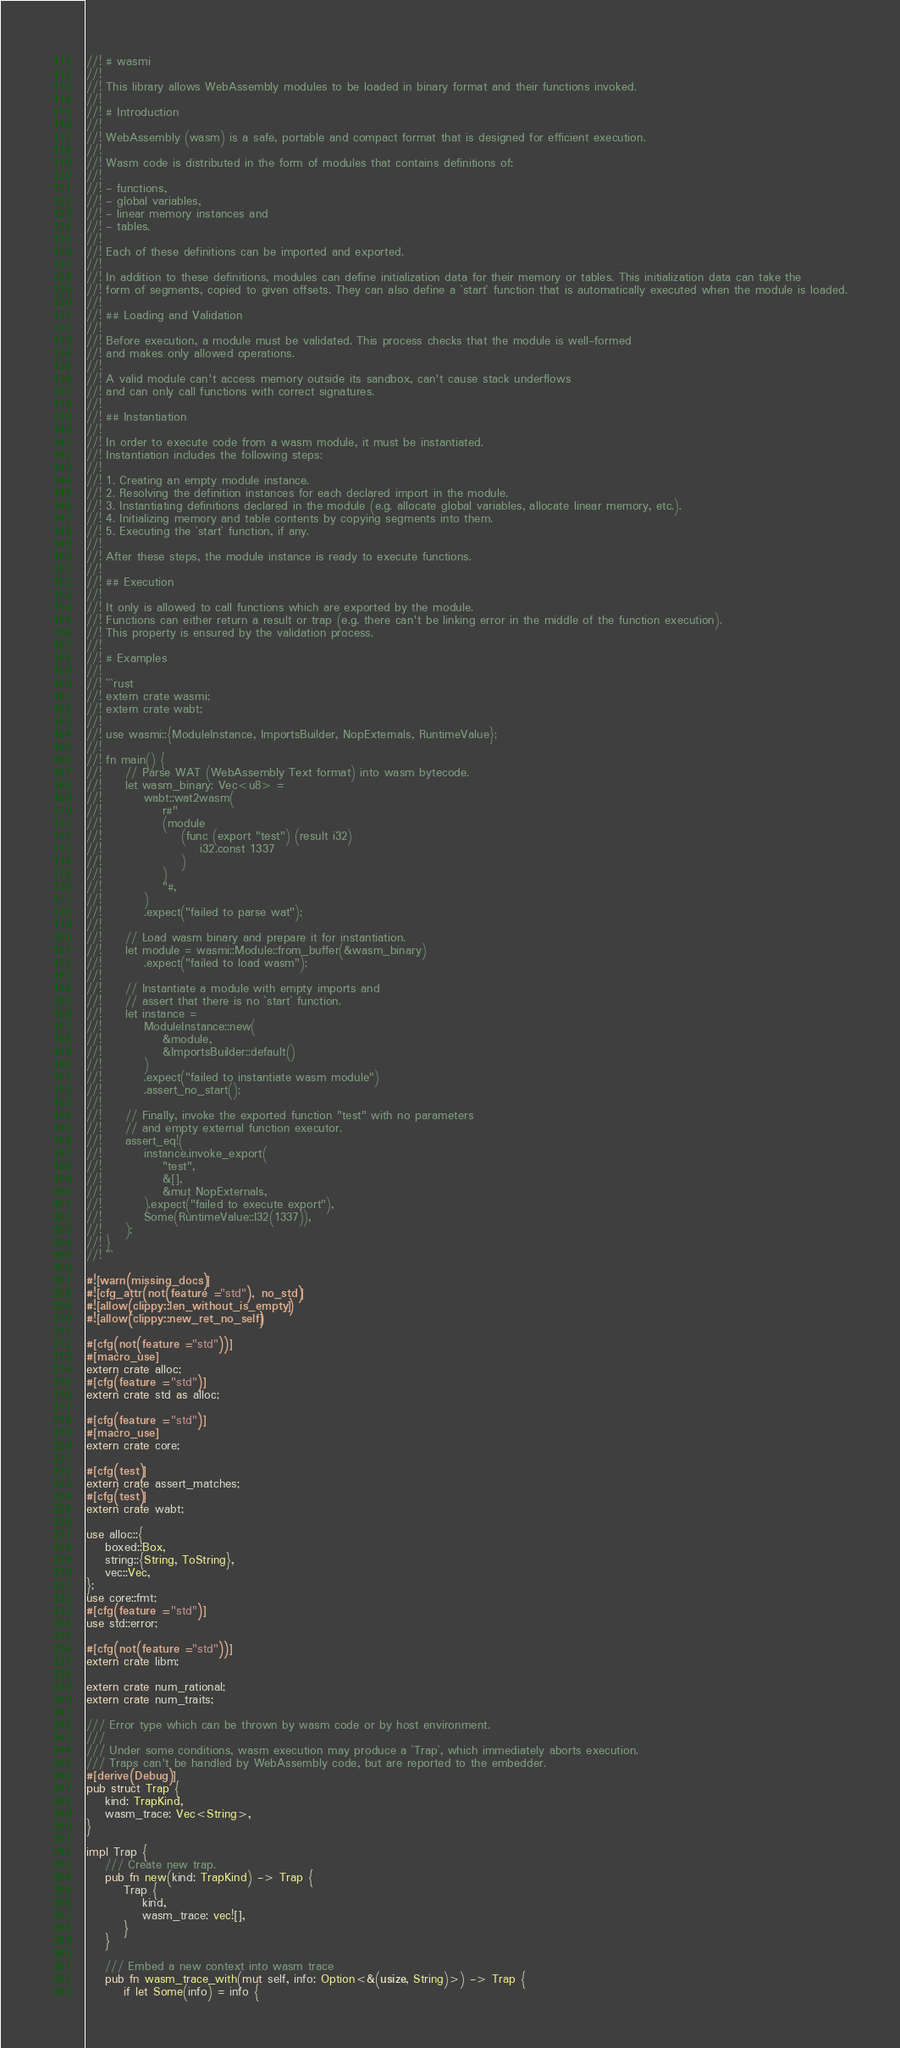<code> <loc_0><loc_0><loc_500><loc_500><_Rust_>//! # wasmi
//!
//! This library allows WebAssembly modules to be loaded in binary format and their functions invoked.
//!
//! # Introduction
//!
//! WebAssembly (wasm) is a safe, portable and compact format that is designed for efficient execution.
//!
//! Wasm code is distributed in the form of modules that contains definitions of:
//!
//! - functions,
//! - global variables,
//! - linear memory instances and
//! - tables.
//!
//! Each of these definitions can be imported and exported.
//!
//! In addition to these definitions, modules can define initialization data for their memory or tables. This initialization data can take the
//! form of segments, copied to given offsets. They can also define a `start` function that is automatically executed when the module is loaded.
//!
//! ## Loading and Validation
//!
//! Before execution, a module must be validated. This process checks that the module is well-formed
//! and makes only allowed operations.
//!
//! A valid module can't access memory outside its sandbox, can't cause stack underflows
//! and can only call functions with correct signatures.
//!
//! ## Instantiation
//!
//! In order to execute code from a wasm module, it must be instantiated.
//! Instantiation includes the following steps:
//!
//! 1. Creating an empty module instance.
//! 2. Resolving the definition instances for each declared import in the module.
//! 3. Instantiating definitions declared in the module (e.g. allocate global variables, allocate linear memory, etc.).
//! 4. Initializing memory and table contents by copying segments into them.
//! 5. Executing the `start` function, if any.
//!
//! After these steps, the module instance is ready to execute functions.
//!
//! ## Execution
//!
//! It only is allowed to call functions which are exported by the module.
//! Functions can either return a result or trap (e.g. there can't be linking error in the middle of the function execution).
//! This property is ensured by the validation process.
//!
//! # Examples
//!
//! ```rust
//! extern crate wasmi;
//! extern crate wabt;
//!
//! use wasmi::{ModuleInstance, ImportsBuilder, NopExternals, RuntimeValue};
//!
//! fn main() {
//!     // Parse WAT (WebAssembly Text format) into wasm bytecode.
//!     let wasm_binary: Vec<u8> =
//!         wabt::wat2wasm(
//!             r#"
//!             (module
//!                 (func (export "test") (result i32)
//!                     i32.const 1337
//!                 )
//!             )
//!             "#,
//!         )
//!         .expect("failed to parse wat");
//!
//!     // Load wasm binary and prepare it for instantiation.
//!     let module = wasmi::Module::from_buffer(&wasm_binary)
//!         .expect("failed to load wasm");
//!
//!     // Instantiate a module with empty imports and
//!     // assert that there is no `start` function.
//!     let instance =
//!         ModuleInstance::new(
//!             &module,
//!             &ImportsBuilder::default()
//!         )
//!         .expect("failed to instantiate wasm module")
//!         .assert_no_start();
//!
//!     // Finally, invoke the exported function "test" with no parameters
//!     // and empty external function executor.
//!     assert_eq!(
//!         instance.invoke_export(
//!             "test",
//!             &[],
//!             &mut NopExternals,
//!         ).expect("failed to execute export"),
//!         Some(RuntimeValue::I32(1337)),
//!     );
//! }
//! ```

#![warn(missing_docs)]
#![cfg_attr(not(feature = "std"), no_std)]
#![allow(clippy::len_without_is_empty)]
#![allow(clippy::new_ret_no_self)]

#[cfg(not(feature = "std"))]
#[macro_use]
extern crate alloc;
#[cfg(feature = "std")]
extern crate std as alloc;

#[cfg(feature = "std")]
#[macro_use]
extern crate core;

#[cfg(test)]
extern crate assert_matches;
#[cfg(test)]
extern crate wabt;

use alloc::{
    boxed::Box,
    string::{String, ToString},
    vec::Vec,
};
use core::fmt;
#[cfg(feature = "std")]
use std::error;

#[cfg(not(feature = "std"))]
extern crate libm;

extern crate num_rational;
extern crate num_traits;

/// Error type which can be thrown by wasm code or by host environment.
///
/// Under some conditions, wasm execution may produce a `Trap`, which immediately aborts execution.
/// Traps can't be handled by WebAssembly code, but are reported to the embedder.
#[derive(Debug)]
pub struct Trap {
    kind: TrapKind,
    wasm_trace: Vec<String>,
}

impl Trap {
    /// Create new trap.
    pub fn new(kind: TrapKind) -> Trap {
        Trap {
            kind,
            wasm_trace: vec![],
        }
    }

    /// Embed a new context into wasm trace
    pub fn wasm_trace_with(mut self, info: Option<&(usize, String)>) -> Trap {
        if let Some(info) = info {</code> 